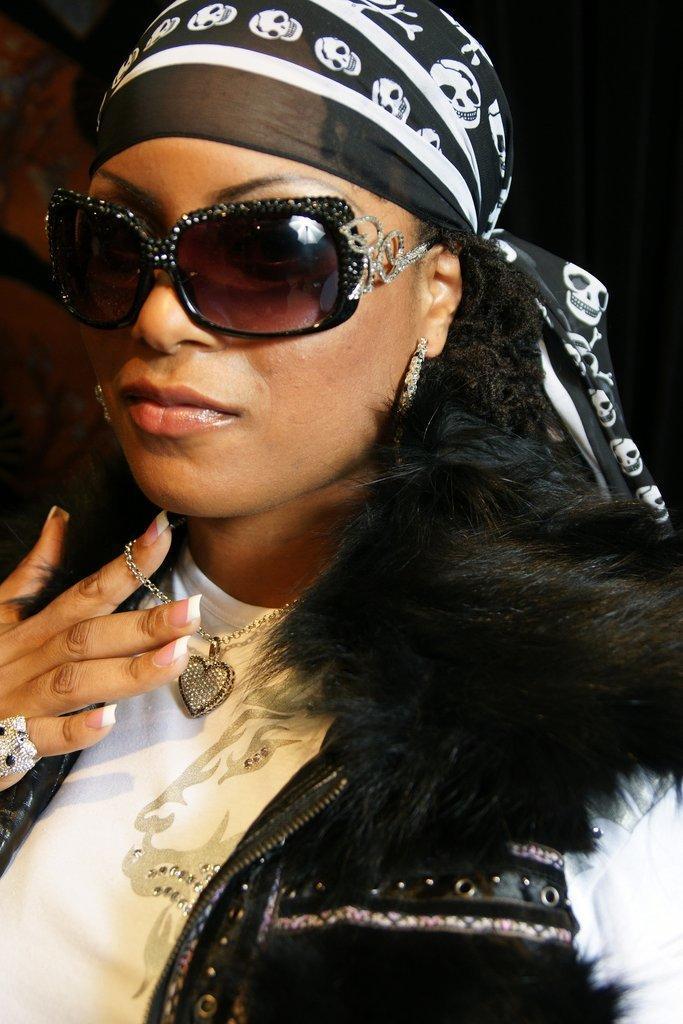Can you describe this image briefly? In this image I can see a woman, she is wearing goggles, white color t-shirt, black color coat. 